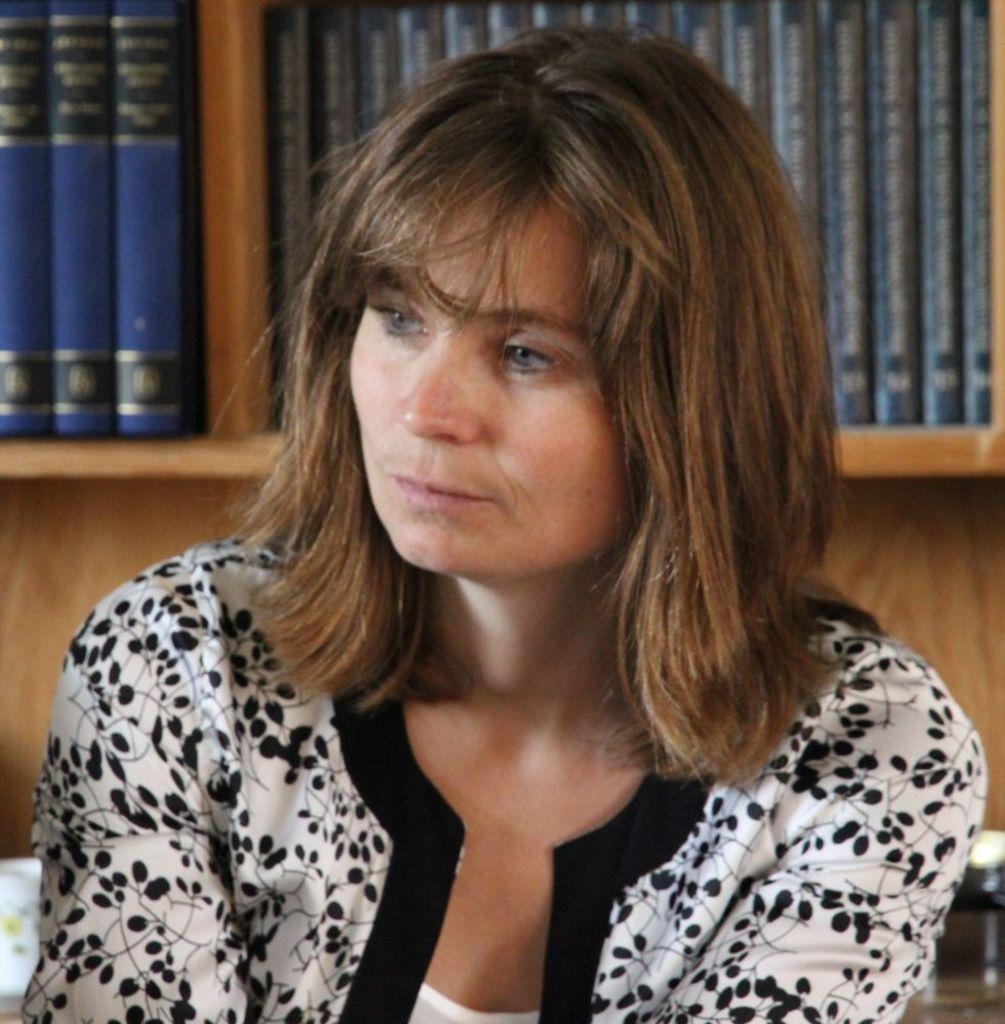Who is present in the image? There is a woman in the image. What is the woman wearing? The woman is wearing a white and black dress. What can be seen in the background of the image? There are books on a rack in the background of the image. What type of string is the woman using to form a dog in the image? There is no string or dog present in the image; it features a woman wearing a white and black dress with books on a rack in the background. 